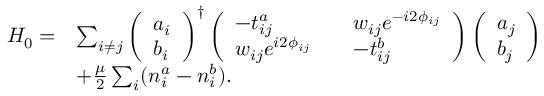<formula> <loc_0><loc_0><loc_500><loc_500>\begin{array} { r l } { H _ { 0 } = } & { \sum _ { i \neq j } \left ( \begin{array} { l } { a _ { i } } \\ { b _ { i } } \end{array} \right ) ^ { \dagger } \left ( \begin{array} { l l l } { - t _ { i j } ^ { a } } & & { w _ { i j } e ^ { - i 2 \phi _ { i j } } } \\ { w _ { i j } e ^ { i 2 \phi _ { i j } } } & & { - t _ { i j } ^ { b } } \end{array} \right ) \left ( \begin{array} { l } { a _ { j } } \\ { b _ { j } } \end{array} \right ) } \\ & { + \frac { \mu } { 2 } \sum _ { i } ( n _ { i } ^ { a } - n _ { i } ^ { b } ) . } \end{array}</formula> 